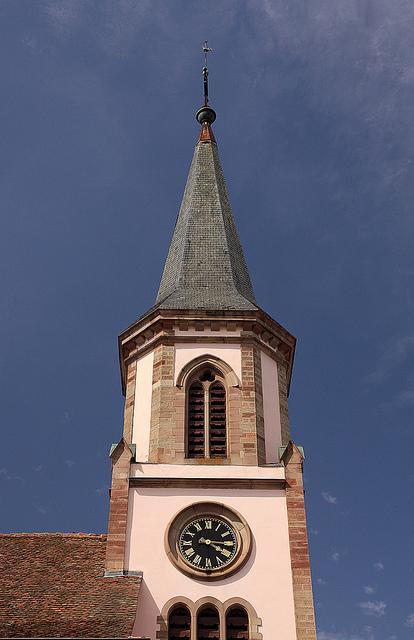What time is it?
Give a very brief answer. 4:15. What kind of building is this?
Concise answer only. Church. What are the white things in the bottom right corner?
Short answer required. Clouds. 